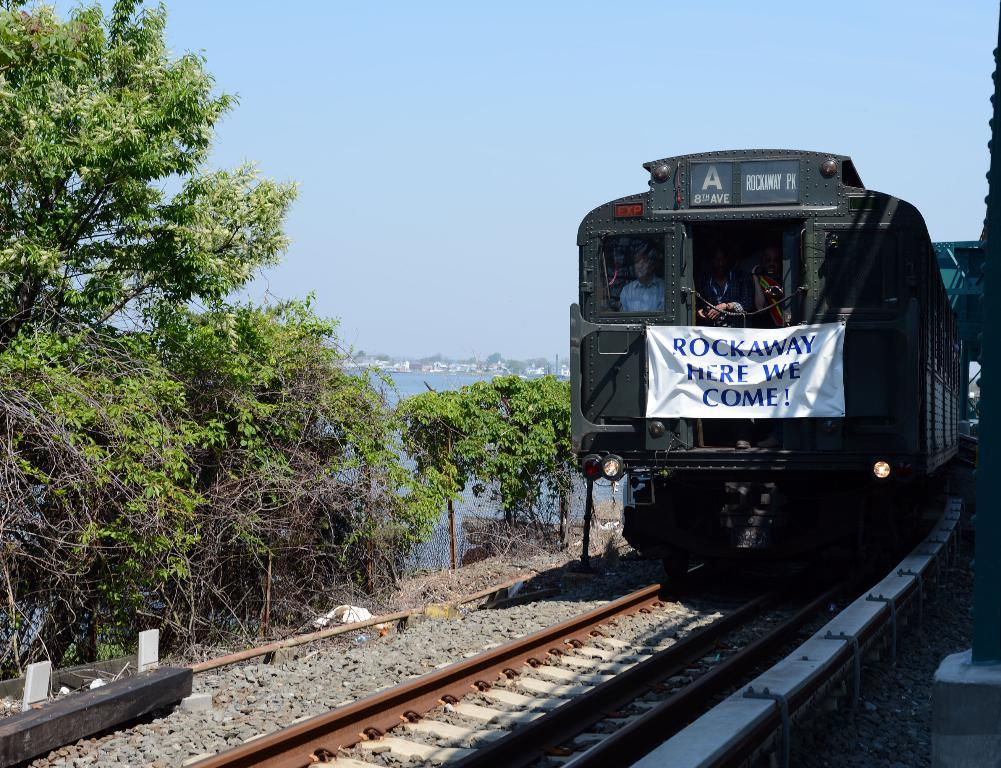<image>
Offer a succinct explanation of the picture presented. A train with a sign in front that reads "ROCKAWAY HERE WE COME!" 